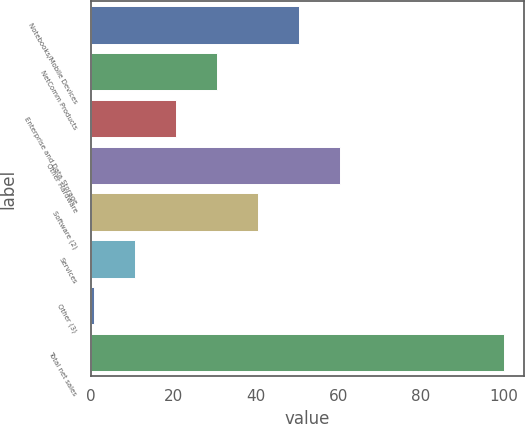Convert chart. <chart><loc_0><loc_0><loc_500><loc_500><bar_chart><fcel>Notebooks/Mobile Devices<fcel>NetComm Products<fcel>Enterprise and Data Storage<fcel>Other Hardware<fcel>Software (2)<fcel>Services<fcel>Other (3)<fcel>Total net sales<nl><fcel>50.35<fcel>30.49<fcel>20.56<fcel>60.28<fcel>40.42<fcel>10.63<fcel>0.7<fcel>100<nl></chart> 